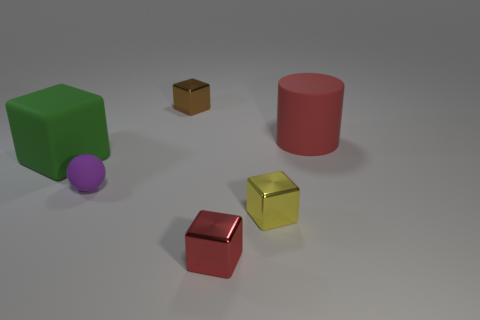What material is the big green object?
Provide a short and direct response. Rubber. There is a small thing in front of the yellow metallic thing; does it have the same shape as the large green object?
Your response must be concise. Yes. The metal block that is the same color as the large cylinder is what size?
Provide a succinct answer. Small. Are there any other yellow cylinders that have the same size as the cylinder?
Offer a terse response. No. Is there a purple object in front of the big rubber thing that is right of the shiny cube behind the yellow thing?
Make the answer very short. Yes. Is the color of the matte cube the same as the tiny metal cube behind the red cylinder?
Offer a terse response. No. There is a block that is right of the red object that is in front of the green object left of the small brown cube; what is its material?
Your answer should be compact. Metal. There is a shiny object that is to the right of the small red shiny object; what is its shape?
Give a very brief answer. Cube. There is a purple sphere that is the same material as the big green block; what size is it?
Your response must be concise. Small. What number of yellow shiny things have the same shape as the small red shiny thing?
Provide a short and direct response. 1. 